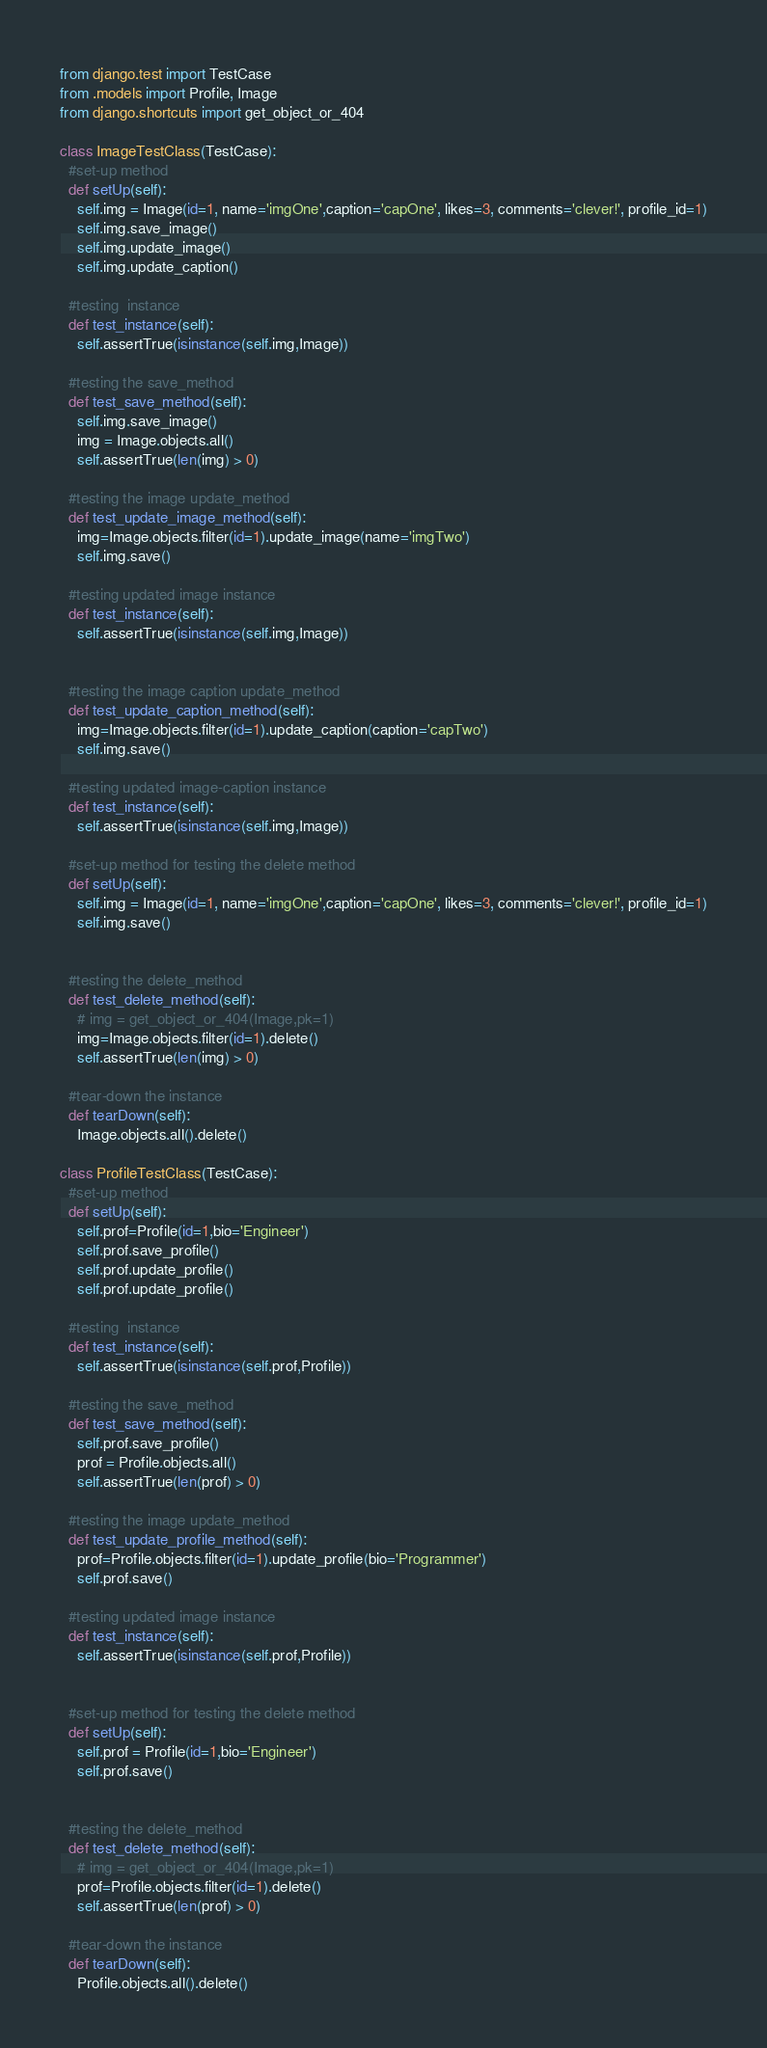<code> <loc_0><loc_0><loc_500><loc_500><_Python_>from django.test import TestCase
from .models import Profile, Image
from django.shortcuts import get_object_or_404

class ImageTestClass(TestCase):
  #set-up method
  def setUp(self):
    self.img = Image(id=1, name='imgOne',caption='capOne', likes=3, comments='clever!', profile_id=1)
    self.img.save_image()
    self.img.update_image()
    self.img.update_caption()
        
  #testing  instance
  def test_instance(self):
    self.assertTrue(isinstance(self.img,Image))
    
  #testing the save_method
  def test_save_method(self):
    self.img.save_image()
    img = Image.objects.all()
    self.assertTrue(len(img) > 0)
        
  #testing the image update_method
  def test_update_image_method(self):
    img=Image.objects.filter(id=1).update_image(name='imgTwo')
    self.img.save()
    
  #testing updated image instance
  def test_instance(self):
    self.assertTrue(isinstance(self.img,Image))
        

  #testing the image caption update_method
  def test_update_caption_method(self):
    img=Image.objects.filter(id=1).update_caption(caption='capTwo')
    self.img.save()
    
  #testing updated image-caption instance
  def test_instance(self):
    self.assertTrue(isinstance(self.img,Image))

  #set-up method for testing the delete method
  def setUp(self):
    self.img = Image(id=1, name='imgOne',caption='capOne', likes=3, comments='clever!', profile_id=1)
    self.img.save()
        
        
  #testing the delete_method
  def test_delete_method(self):
    # img = get_object_or_404(Image,pk=1)
    img=Image.objects.filter(id=1).delete()
    self.assertTrue(len(img) > 0)
    
  #tear-down the instance
  def tearDown(self):
    Image.objects.all().delete()

class ProfileTestClass(TestCase):
  #set-up method
  def setUp(self):
    self.prof=Profile(id=1,bio='Engineer')
    self.prof.save_profile()
    self.prof.update_profile()
    self.prof.update_profile()
        
  #testing  instance
  def test_instance(self):
    self.assertTrue(isinstance(self.prof,Profile))
    
  #testing the save_method
  def test_save_method(self):
    self.prof.save_profile()
    prof = Profile.objects.all()
    self.assertTrue(len(prof) > 0)
        
  #testing the image update_method
  def test_update_profile_method(self):
    prof=Profile.objects.filter(id=1).update_profile(bio='Programmer')
    self.prof.save()
    
  #testing updated image instance
  def test_instance(self):
    self.assertTrue(isinstance(self.prof,Profile))
        

  #set-up method for testing the delete method
  def setUp(self):
    self.prof = Profile(id=1,bio='Engineer')
    self.prof.save()
        
        
  #testing the delete_method
  def test_delete_method(self):
    # img = get_object_or_404(Image,pk=1)
    prof=Profile.objects.filter(id=1).delete()
    self.assertTrue(len(prof) > 0)
    
  #tear-down the instance
  def tearDown(self):
    Profile.objects.all().delete()</code> 